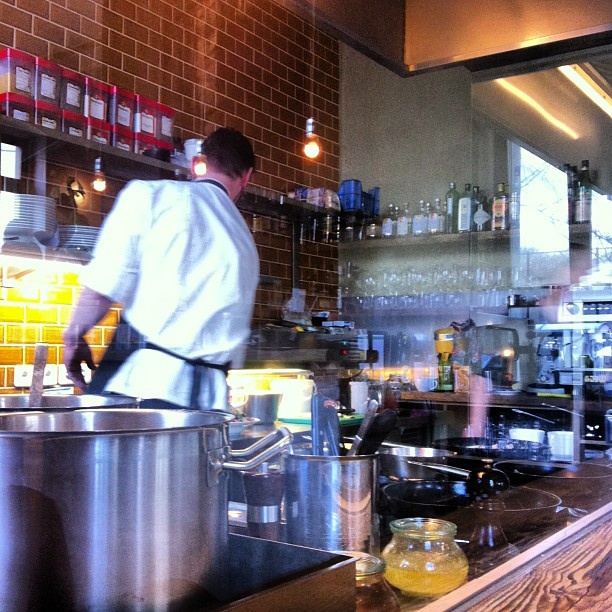Describe the objects in this image and their specific colors. I can see people in salmon, ivory, darkgray, lightblue, and black tones, bowl in salmon, black, gray, and navy tones, bowl in salmon, black, and purple tones, bottle in salmon, gray, blue, darkgray, and black tones, and bottle in salmon, black, darkgray, and gray tones in this image. 